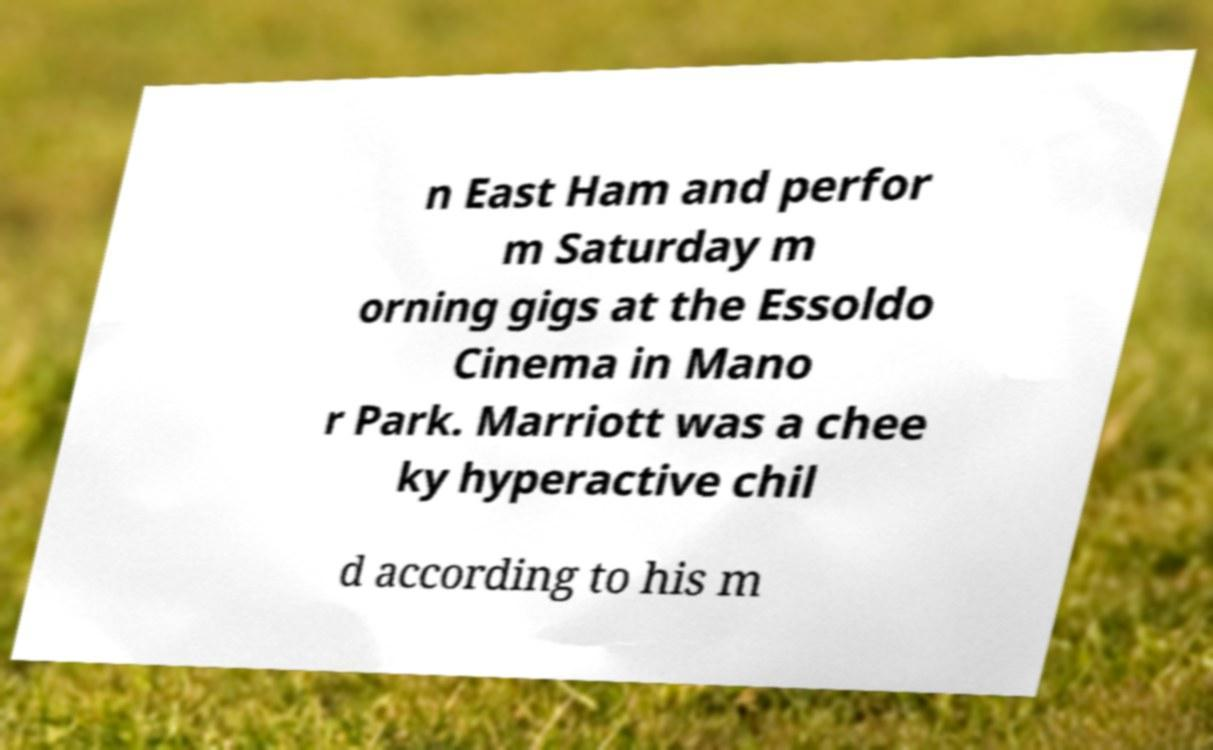Can you accurately transcribe the text from the provided image for me? n East Ham and perfor m Saturday m orning gigs at the Essoldo Cinema in Mano r Park. Marriott was a chee ky hyperactive chil d according to his m 